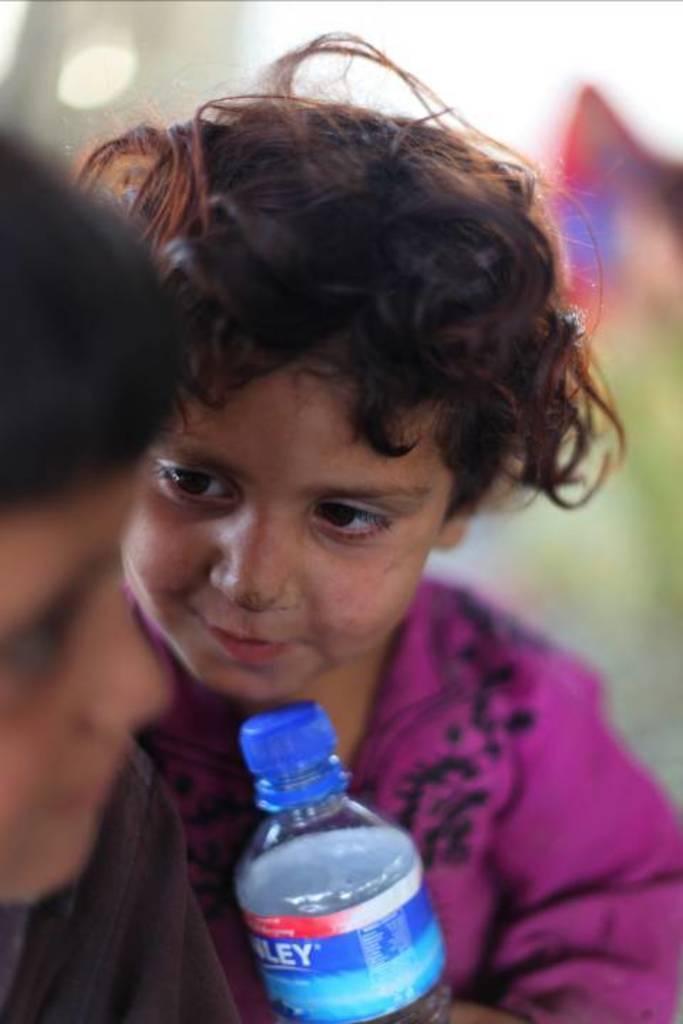In one or two sentences, can you explain what this image depicts? In this image I see a child who is wearing a pink dress and there is a bottle over here , I can also see there is another child over here. 